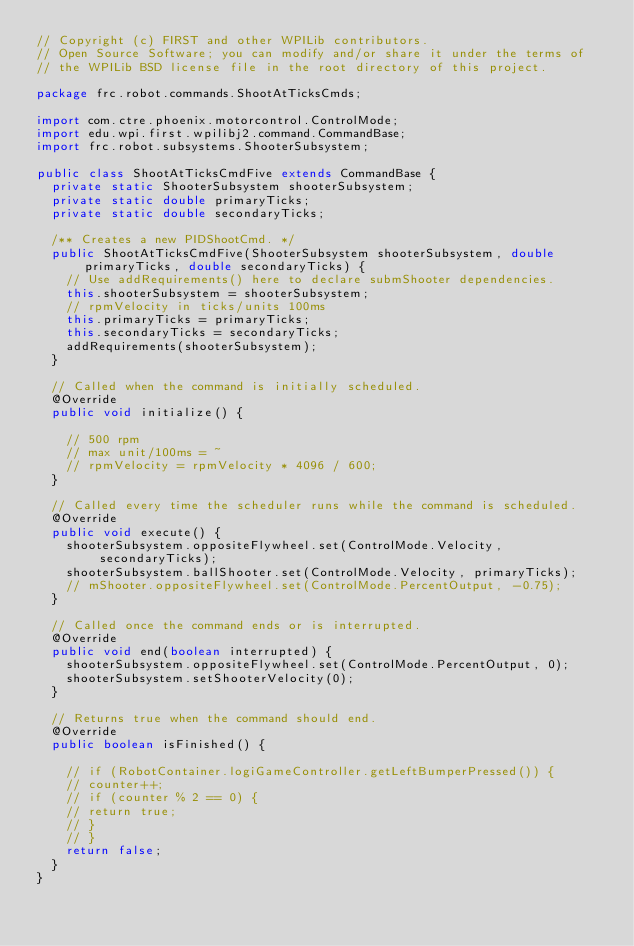Convert code to text. <code><loc_0><loc_0><loc_500><loc_500><_Java_>// Copyright (c) FIRST and other WPILib contributors.
// Open Source Software; you can modify and/or share it under the terms of
// the WPILib BSD license file in the root directory of this project.

package frc.robot.commands.ShootAtTicksCmds;

import com.ctre.phoenix.motorcontrol.ControlMode;
import edu.wpi.first.wpilibj2.command.CommandBase;
import frc.robot.subsystems.ShooterSubsystem;

public class ShootAtTicksCmdFive extends CommandBase {
  private static ShooterSubsystem shooterSubsystem;
  private static double primaryTicks;
  private static double secondaryTicks;

  /** Creates a new PIDShootCmd. */
  public ShootAtTicksCmdFive(ShooterSubsystem shooterSubsystem, double primaryTicks, double secondaryTicks) {
    // Use addRequirements() here to declare submShooter dependencies.
    this.shooterSubsystem = shooterSubsystem;
    // rpmVelocity in ticks/units 100ms
    this.primaryTicks = primaryTicks;
    this.secondaryTicks = secondaryTicks;
    addRequirements(shooterSubsystem);
  }

  // Called when the command is initially scheduled.
  @Override
  public void initialize() {

    // 500 rpm
    // max unit/100ms = ~
    // rpmVelocity = rpmVelocity * 4096 / 600;
  }

  // Called every time the scheduler runs while the command is scheduled.
  @Override
  public void execute() {
    shooterSubsystem.oppositeFlywheel.set(ControlMode.Velocity, secondaryTicks);
    shooterSubsystem.ballShooter.set(ControlMode.Velocity, primaryTicks);
    // mShooter.oppositeFlywheel.set(ControlMode.PercentOutput, -0.75);
  }

  // Called once the command ends or is interrupted.
  @Override
  public void end(boolean interrupted) {
    shooterSubsystem.oppositeFlywheel.set(ControlMode.PercentOutput, 0);
    shooterSubsystem.setShooterVelocity(0);
  }

  // Returns true when the command should end.
  @Override
  public boolean isFinished() {

    // if (RobotContainer.logiGameController.getLeftBumperPressed()) {
    // counter++;
    // if (counter % 2 == 0) {
    // return true;
    // }
    // }
    return false;
  }
}
</code> 